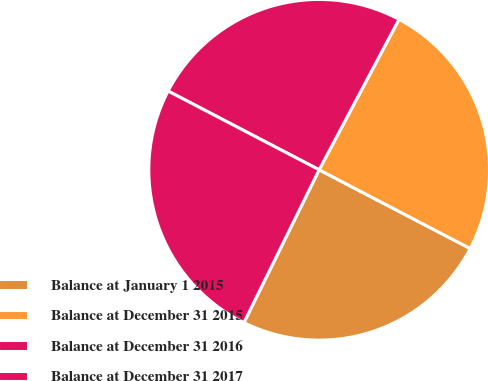Convert chart to OTSL. <chart><loc_0><loc_0><loc_500><loc_500><pie_chart><fcel>Balance at January 1 2015<fcel>Balance at December 31 2015<fcel>Balance at December 31 2016<fcel>Balance at December 31 2017<nl><fcel>24.63%<fcel>24.88%<fcel>25.12%<fcel>25.37%<nl></chart> 